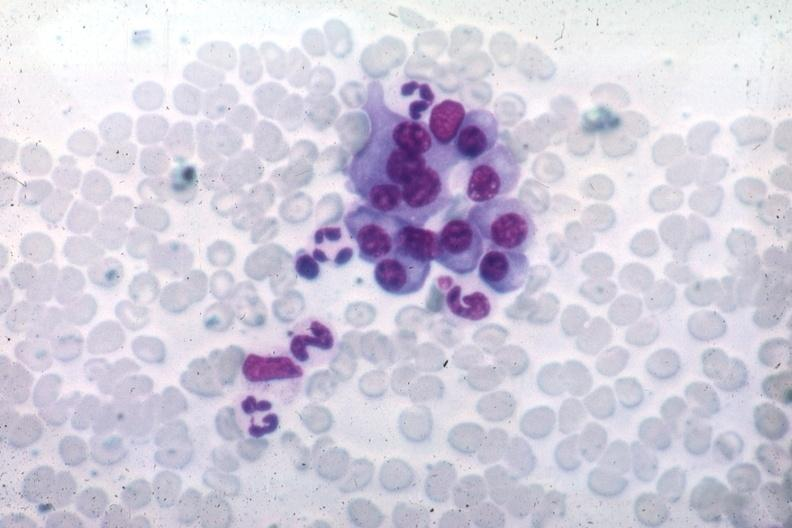how is wrights typical well differentiated plasma cells source?
Answer the question using a single word or phrase. Unknown 